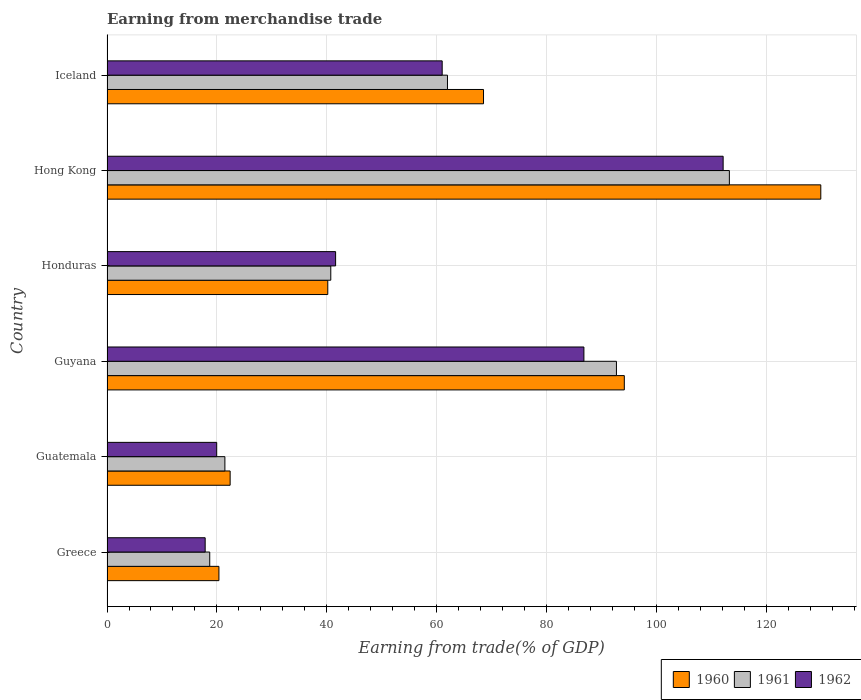How many different coloured bars are there?
Give a very brief answer. 3. How many groups of bars are there?
Offer a very short reply. 6. Are the number of bars on each tick of the Y-axis equal?
Your response must be concise. Yes. What is the label of the 4th group of bars from the top?
Provide a short and direct response. Guyana. In how many cases, is the number of bars for a given country not equal to the number of legend labels?
Keep it short and to the point. 0. What is the earnings from trade in 1961 in Iceland?
Your response must be concise. 61.93. Across all countries, what is the maximum earnings from trade in 1960?
Your response must be concise. 129.85. Across all countries, what is the minimum earnings from trade in 1961?
Give a very brief answer. 18.69. In which country was the earnings from trade in 1962 maximum?
Give a very brief answer. Hong Kong. What is the total earnings from trade in 1960 in the graph?
Offer a terse response. 375.36. What is the difference between the earnings from trade in 1962 in Guatemala and that in Iceland?
Your answer should be compact. -41.02. What is the difference between the earnings from trade in 1961 in Greece and the earnings from trade in 1962 in Hong Kong?
Provide a succinct answer. -93.39. What is the average earnings from trade in 1961 per country?
Offer a very short reply. 58.11. What is the difference between the earnings from trade in 1960 and earnings from trade in 1961 in Guyana?
Offer a terse response. 1.43. What is the ratio of the earnings from trade in 1960 in Guatemala to that in Hong Kong?
Ensure brevity in your answer.  0.17. What is the difference between the highest and the second highest earnings from trade in 1962?
Your answer should be very brief. 25.33. What is the difference between the highest and the lowest earnings from trade in 1962?
Offer a terse response. 94.22. Is the sum of the earnings from trade in 1961 in Guyana and Iceland greater than the maximum earnings from trade in 1960 across all countries?
Provide a succinct answer. Yes. What does the 2nd bar from the bottom in Hong Kong represents?
Offer a terse response. 1961. How many bars are there?
Offer a very short reply. 18. Are the values on the major ticks of X-axis written in scientific E-notation?
Offer a very short reply. No. Does the graph contain grids?
Offer a terse response. Yes. How many legend labels are there?
Provide a short and direct response. 3. What is the title of the graph?
Offer a terse response. Earning from merchandise trade. Does "1972" appear as one of the legend labels in the graph?
Give a very brief answer. No. What is the label or title of the X-axis?
Keep it short and to the point. Earning from trade(% of GDP). What is the label or title of the Y-axis?
Keep it short and to the point. Country. What is the Earning from trade(% of GDP) in 1960 in Greece?
Your answer should be compact. 20.36. What is the Earning from trade(% of GDP) of 1961 in Greece?
Provide a succinct answer. 18.69. What is the Earning from trade(% of GDP) in 1962 in Greece?
Offer a very short reply. 17.86. What is the Earning from trade(% of GDP) in 1960 in Guatemala?
Your answer should be compact. 22.4. What is the Earning from trade(% of GDP) of 1961 in Guatemala?
Make the answer very short. 21.44. What is the Earning from trade(% of GDP) in 1962 in Guatemala?
Make the answer very short. 19.96. What is the Earning from trade(% of GDP) in 1960 in Guyana?
Your answer should be very brief. 94.1. What is the Earning from trade(% of GDP) of 1961 in Guyana?
Make the answer very short. 92.67. What is the Earning from trade(% of GDP) in 1962 in Guyana?
Your answer should be compact. 86.75. What is the Earning from trade(% of GDP) in 1960 in Honduras?
Provide a short and direct response. 40.16. What is the Earning from trade(% of GDP) of 1961 in Honduras?
Keep it short and to the point. 40.71. What is the Earning from trade(% of GDP) in 1962 in Honduras?
Make the answer very short. 41.59. What is the Earning from trade(% of GDP) of 1960 in Hong Kong?
Provide a short and direct response. 129.85. What is the Earning from trade(% of GDP) of 1961 in Hong Kong?
Ensure brevity in your answer.  113.21. What is the Earning from trade(% of GDP) in 1962 in Hong Kong?
Make the answer very short. 112.08. What is the Earning from trade(% of GDP) in 1960 in Iceland?
Offer a very short reply. 68.49. What is the Earning from trade(% of GDP) in 1961 in Iceland?
Offer a very short reply. 61.93. What is the Earning from trade(% of GDP) in 1962 in Iceland?
Keep it short and to the point. 60.97. Across all countries, what is the maximum Earning from trade(% of GDP) in 1960?
Your answer should be very brief. 129.85. Across all countries, what is the maximum Earning from trade(% of GDP) in 1961?
Your answer should be compact. 113.21. Across all countries, what is the maximum Earning from trade(% of GDP) of 1962?
Offer a terse response. 112.08. Across all countries, what is the minimum Earning from trade(% of GDP) in 1960?
Provide a short and direct response. 20.36. Across all countries, what is the minimum Earning from trade(% of GDP) of 1961?
Make the answer very short. 18.69. Across all countries, what is the minimum Earning from trade(% of GDP) in 1962?
Your response must be concise. 17.86. What is the total Earning from trade(% of GDP) in 1960 in the graph?
Your answer should be very brief. 375.36. What is the total Earning from trade(% of GDP) of 1961 in the graph?
Offer a very short reply. 348.66. What is the total Earning from trade(% of GDP) of 1962 in the graph?
Provide a short and direct response. 339.2. What is the difference between the Earning from trade(% of GDP) of 1960 in Greece and that in Guatemala?
Your response must be concise. -2.04. What is the difference between the Earning from trade(% of GDP) in 1961 in Greece and that in Guatemala?
Keep it short and to the point. -2.76. What is the difference between the Earning from trade(% of GDP) in 1962 in Greece and that in Guatemala?
Offer a very short reply. -2.1. What is the difference between the Earning from trade(% of GDP) of 1960 in Greece and that in Guyana?
Make the answer very short. -73.74. What is the difference between the Earning from trade(% of GDP) of 1961 in Greece and that in Guyana?
Make the answer very short. -73.98. What is the difference between the Earning from trade(% of GDP) of 1962 in Greece and that in Guyana?
Ensure brevity in your answer.  -68.9. What is the difference between the Earning from trade(% of GDP) of 1960 in Greece and that in Honduras?
Offer a very short reply. -19.8. What is the difference between the Earning from trade(% of GDP) in 1961 in Greece and that in Honduras?
Make the answer very short. -22.02. What is the difference between the Earning from trade(% of GDP) of 1962 in Greece and that in Honduras?
Offer a terse response. -23.73. What is the difference between the Earning from trade(% of GDP) of 1960 in Greece and that in Hong Kong?
Keep it short and to the point. -109.49. What is the difference between the Earning from trade(% of GDP) in 1961 in Greece and that in Hong Kong?
Your answer should be very brief. -94.53. What is the difference between the Earning from trade(% of GDP) of 1962 in Greece and that in Hong Kong?
Make the answer very short. -94.22. What is the difference between the Earning from trade(% of GDP) of 1960 in Greece and that in Iceland?
Offer a terse response. -48.13. What is the difference between the Earning from trade(% of GDP) of 1961 in Greece and that in Iceland?
Ensure brevity in your answer.  -43.24. What is the difference between the Earning from trade(% of GDP) of 1962 in Greece and that in Iceland?
Provide a short and direct response. -43.12. What is the difference between the Earning from trade(% of GDP) of 1960 in Guatemala and that in Guyana?
Provide a succinct answer. -71.7. What is the difference between the Earning from trade(% of GDP) of 1961 in Guatemala and that in Guyana?
Your answer should be very brief. -71.23. What is the difference between the Earning from trade(% of GDP) in 1962 in Guatemala and that in Guyana?
Your answer should be compact. -66.8. What is the difference between the Earning from trade(% of GDP) in 1960 in Guatemala and that in Honduras?
Your answer should be compact. -17.76. What is the difference between the Earning from trade(% of GDP) of 1961 in Guatemala and that in Honduras?
Give a very brief answer. -19.26. What is the difference between the Earning from trade(% of GDP) of 1962 in Guatemala and that in Honduras?
Ensure brevity in your answer.  -21.63. What is the difference between the Earning from trade(% of GDP) in 1960 in Guatemala and that in Hong Kong?
Keep it short and to the point. -107.45. What is the difference between the Earning from trade(% of GDP) of 1961 in Guatemala and that in Hong Kong?
Offer a terse response. -91.77. What is the difference between the Earning from trade(% of GDP) of 1962 in Guatemala and that in Hong Kong?
Your answer should be compact. -92.13. What is the difference between the Earning from trade(% of GDP) of 1960 in Guatemala and that in Iceland?
Provide a succinct answer. -46.09. What is the difference between the Earning from trade(% of GDP) of 1961 in Guatemala and that in Iceland?
Give a very brief answer. -40.49. What is the difference between the Earning from trade(% of GDP) in 1962 in Guatemala and that in Iceland?
Offer a very short reply. -41.02. What is the difference between the Earning from trade(% of GDP) of 1960 in Guyana and that in Honduras?
Your answer should be very brief. 53.94. What is the difference between the Earning from trade(% of GDP) in 1961 in Guyana and that in Honduras?
Keep it short and to the point. 51.96. What is the difference between the Earning from trade(% of GDP) in 1962 in Guyana and that in Honduras?
Keep it short and to the point. 45.17. What is the difference between the Earning from trade(% of GDP) of 1960 in Guyana and that in Hong Kong?
Give a very brief answer. -35.74. What is the difference between the Earning from trade(% of GDP) of 1961 in Guyana and that in Hong Kong?
Provide a succinct answer. -20.54. What is the difference between the Earning from trade(% of GDP) in 1962 in Guyana and that in Hong Kong?
Offer a terse response. -25.33. What is the difference between the Earning from trade(% of GDP) in 1960 in Guyana and that in Iceland?
Provide a succinct answer. 25.61. What is the difference between the Earning from trade(% of GDP) in 1961 in Guyana and that in Iceland?
Ensure brevity in your answer.  30.74. What is the difference between the Earning from trade(% of GDP) in 1962 in Guyana and that in Iceland?
Keep it short and to the point. 25.78. What is the difference between the Earning from trade(% of GDP) of 1960 in Honduras and that in Hong Kong?
Offer a very short reply. -89.68. What is the difference between the Earning from trade(% of GDP) of 1961 in Honduras and that in Hong Kong?
Offer a very short reply. -72.51. What is the difference between the Earning from trade(% of GDP) of 1962 in Honduras and that in Hong Kong?
Offer a very short reply. -70.49. What is the difference between the Earning from trade(% of GDP) of 1960 in Honduras and that in Iceland?
Offer a terse response. -28.33. What is the difference between the Earning from trade(% of GDP) of 1961 in Honduras and that in Iceland?
Ensure brevity in your answer.  -21.23. What is the difference between the Earning from trade(% of GDP) of 1962 in Honduras and that in Iceland?
Provide a succinct answer. -19.39. What is the difference between the Earning from trade(% of GDP) in 1960 in Hong Kong and that in Iceland?
Your answer should be very brief. 61.35. What is the difference between the Earning from trade(% of GDP) of 1961 in Hong Kong and that in Iceland?
Make the answer very short. 51.28. What is the difference between the Earning from trade(% of GDP) of 1962 in Hong Kong and that in Iceland?
Make the answer very short. 51.11. What is the difference between the Earning from trade(% of GDP) of 1960 in Greece and the Earning from trade(% of GDP) of 1961 in Guatemala?
Offer a very short reply. -1.09. What is the difference between the Earning from trade(% of GDP) of 1960 in Greece and the Earning from trade(% of GDP) of 1962 in Guatemala?
Provide a short and direct response. 0.4. What is the difference between the Earning from trade(% of GDP) of 1961 in Greece and the Earning from trade(% of GDP) of 1962 in Guatemala?
Offer a very short reply. -1.27. What is the difference between the Earning from trade(% of GDP) in 1960 in Greece and the Earning from trade(% of GDP) in 1961 in Guyana?
Make the answer very short. -72.31. What is the difference between the Earning from trade(% of GDP) in 1960 in Greece and the Earning from trade(% of GDP) in 1962 in Guyana?
Keep it short and to the point. -66.4. What is the difference between the Earning from trade(% of GDP) in 1961 in Greece and the Earning from trade(% of GDP) in 1962 in Guyana?
Your answer should be compact. -68.07. What is the difference between the Earning from trade(% of GDP) of 1960 in Greece and the Earning from trade(% of GDP) of 1961 in Honduras?
Your response must be concise. -20.35. What is the difference between the Earning from trade(% of GDP) of 1960 in Greece and the Earning from trade(% of GDP) of 1962 in Honduras?
Offer a terse response. -21.23. What is the difference between the Earning from trade(% of GDP) in 1961 in Greece and the Earning from trade(% of GDP) in 1962 in Honduras?
Your answer should be very brief. -22.9. What is the difference between the Earning from trade(% of GDP) in 1960 in Greece and the Earning from trade(% of GDP) in 1961 in Hong Kong?
Your answer should be compact. -92.86. What is the difference between the Earning from trade(% of GDP) of 1960 in Greece and the Earning from trade(% of GDP) of 1962 in Hong Kong?
Offer a terse response. -91.72. What is the difference between the Earning from trade(% of GDP) in 1961 in Greece and the Earning from trade(% of GDP) in 1962 in Hong Kong?
Provide a succinct answer. -93.39. What is the difference between the Earning from trade(% of GDP) of 1960 in Greece and the Earning from trade(% of GDP) of 1961 in Iceland?
Provide a succinct answer. -41.58. What is the difference between the Earning from trade(% of GDP) of 1960 in Greece and the Earning from trade(% of GDP) of 1962 in Iceland?
Make the answer very short. -40.62. What is the difference between the Earning from trade(% of GDP) of 1961 in Greece and the Earning from trade(% of GDP) of 1962 in Iceland?
Offer a terse response. -42.28. What is the difference between the Earning from trade(% of GDP) in 1960 in Guatemala and the Earning from trade(% of GDP) in 1961 in Guyana?
Your answer should be very brief. -70.27. What is the difference between the Earning from trade(% of GDP) in 1960 in Guatemala and the Earning from trade(% of GDP) in 1962 in Guyana?
Make the answer very short. -64.35. What is the difference between the Earning from trade(% of GDP) in 1961 in Guatemala and the Earning from trade(% of GDP) in 1962 in Guyana?
Your response must be concise. -65.31. What is the difference between the Earning from trade(% of GDP) of 1960 in Guatemala and the Earning from trade(% of GDP) of 1961 in Honduras?
Provide a succinct answer. -18.31. What is the difference between the Earning from trade(% of GDP) of 1960 in Guatemala and the Earning from trade(% of GDP) of 1962 in Honduras?
Ensure brevity in your answer.  -19.19. What is the difference between the Earning from trade(% of GDP) in 1961 in Guatemala and the Earning from trade(% of GDP) in 1962 in Honduras?
Keep it short and to the point. -20.14. What is the difference between the Earning from trade(% of GDP) in 1960 in Guatemala and the Earning from trade(% of GDP) in 1961 in Hong Kong?
Provide a succinct answer. -90.81. What is the difference between the Earning from trade(% of GDP) in 1960 in Guatemala and the Earning from trade(% of GDP) in 1962 in Hong Kong?
Make the answer very short. -89.68. What is the difference between the Earning from trade(% of GDP) in 1961 in Guatemala and the Earning from trade(% of GDP) in 1962 in Hong Kong?
Give a very brief answer. -90.64. What is the difference between the Earning from trade(% of GDP) in 1960 in Guatemala and the Earning from trade(% of GDP) in 1961 in Iceland?
Provide a succinct answer. -39.53. What is the difference between the Earning from trade(% of GDP) in 1960 in Guatemala and the Earning from trade(% of GDP) in 1962 in Iceland?
Give a very brief answer. -38.57. What is the difference between the Earning from trade(% of GDP) in 1961 in Guatemala and the Earning from trade(% of GDP) in 1962 in Iceland?
Ensure brevity in your answer.  -39.53. What is the difference between the Earning from trade(% of GDP) in 1960 in Guyana and the Earning from trade(% of GDP) in 1961 in Honduras?
Keep it short and to the point. 53.39. What is the difference between the Earning from trade(% of GDP) of 1960 in Guyana and the Earning from trade(% of GDP) of 1962 in Honduras?
Give a very brief answer. 52.52. What is the difference between the Earning from trade(% of GDP) of 1961 in Guyana and the Earning from trade(% of GDP) of 1962 in Honduras?
Your response must be concise. 51.09. What is the difference between the Earning from trade(% of GDP) of 1960 in Guyana and the Earning from trade(% of GDP) of 1961 in Hong Kong?
Provide a succinct answer. -19.11. What is the difference between the Earning from trade(% of GDP) in 1960 in Guyana and the Earning from trade(% of GDP) in 1962 in Hong Kong?
Your answer should be very brief. -17.98. What is the difference between the Earning from trade(% of GDP) in 1961 in Guyana and the Earning from trade(% of GDP) in 1962 in Hong Kong?
Make the answer very short. -19.41. What is the difference between the Earning from trade(% of GDP) of 1960 in Guyana and the Earning from trade(% of GDP) of 1961 in Iceland?
Ensure brevity in your answer.  32.17. What is the difference between the Earning from trade(% of GDP) in 1960 in Guyana and the Earning from trade(% of GDP) in 1962 in Iceland?
Offer a terse response. 33.13. What is the difference between the Earning from trade(% of GDP) of 1961 in Guyana and the Earning from trade(% of GDP) of 1962 in Iceland?
Ensure brevity in your answer.  31.7. What is the difference between the Earning from trade(% of GDP) in 1960 in Honduras and the Earning from trade(% of GDP) in 1961 in Hong Kong?
Give a very brief answer. -73.05. What is the difference between the Earning from trade(% of GDP) in 1960 in Honduras and the Earning from trade(% of GDP) in 1962 in Hong Kong?
Offer a very short reply. -71.92. What is the difference between the Earning from trade(% of GDP) in 1961 in Honduras and the Earning from trade(% of GDP) in 1962 in Hong Kong?
Make the answer very short. -71.37. What is the difference between the Earning from trade(% of GDP) in 1960 in Honduras and the Earning from trade(% of GDP) in 1961 in Iceland?
Offer a terse response. -21.77. What is the difference between the Earning from trade(% of GDP) in 1960 in Honduras and the Earning from trade(% of GDP) in 1962 in Iceland?
Make the answer very short. -20.81. What is the difference between the Earning from trade(% of GDP) in 1961 in Honduras and the Earning from trade(% of GDP) in 1962 in Iceland?
Your response must be concise. -20.27. What is the difference between the Earning from trade(% of GDP) in 1960 in Hong Kong and the Earning from trade(% of GDP) in 1961 in Iceland?
Make the answer very short. 67.91. What is the difference between the Earning from trade(% of GDP) in 1960 in Hong Kong and the Earning from trade(% of GDP) in 1962 in Iceland?
Give a very brief answer. 68.87. What is the difference between the Earning from trade(% of GDP) of 1961 in Hong Kong and the Earning from trade(% of GDP) of 1962 in Iceland?
Give a very brief answer. 52.24. What is the average Earning from trade(% of GDP) of 1960 per country?
Give a very brief answer. 62.56. What is the average Earning from trade(% of GDP) of 1961 per country?
Keep it short and to the point. 58.11. What is the average Earning from trade(% of GDP) in 1962 per country?
Provide a short and direct response. 56.53. What is the difference between the Earning from trade(% of GDP) of 1960 and Earning from trade(% of GDP) of 1961 in Greece?
Ensure brevity in your answer.  1.67. What is the difference between the Earning from trade(% of GDP) of 1960 and Earning from trade(% of GDP) of 1962 in Greece?
Ensure brevity in your answer.  2.5. What is the difference between the Earning from trade(% of GDP) in 1961 and Earning from trade(% of GDP) in 1962 in Greece?
Provide a succinct answer. 0.83. What is the difference between the Earning from trade(% of GDP) of 1960 and Earning from trade(% of GDP) of 1961 in Guatemala?
Provide a succinct answer. 0.96. What is the difference between the Earning from trade(% of GDP) in 1960 and Earning from trade(% of GDP) in 1962 in Guatemala?
Provide a succinct answer. 2.44. What is the difference between the Earning from trade(% of GDP) of 1961 and Earning from trade(% of GDP) of 1962 in Guatemala?
Your answer should be compact. 1.49. What is the difference between the Earning from trade(% of GDP) of 1960 and Earning from trade(% of GDP) of 1961 in Guyana?
Keep it short and to the point. 1.43. What is the difference between the Earning from trade(% of GDP) of 1960 and Earning from trade(% of GDP) of 1962 in Guyana?
Your answer should be compact. 7.35. What is the difference between the Earning from trade(% of GDP) in 1961 and Earning from trade(% of GDP) in 1962 in Guyana?
Keep it short and to the point. 5.92. What is the difference between the Earning from trade(% of GDP) of 1960 and Earning from trade(% of GDP) of 1961 in Honduras?
Make the answer very short. -0.55. What is the difference between the Earning from trade(% of GDP) of 1960 and Earning from trade(% of GDP) of 1962 in Honduras?
Make the answer very short. -1.43. What is the difference between the Earning from trade(% of GDP) in 1961 and Earning from trade(% of GDP) in 1962 in Honduras?
Make the answer very short. -0.88. What is the difference between the Earning from trade(% of GDP) of 1960 and Earning from trade(% of GDP) of 1961 in Hong Kong?
Provide a short and direct response. 16.63. What is the difference between the Earning from trade(% of GDP) of 1960 and Earning from trade(% of GDP) of 1962 in Hong Kong?
Offer a very short reply. 17.76. What is the difference between the Earning from trade(% of GDP) of 1961 and Earning from trade(% of GDP) of 1962 in Hong Kong?
Your response must be concise. 1.13. What is the difference between the Earning from trade(% of GDP) of 1960 and Earning from trade(% of GDP) of 1961 in Iceland?
Your answer should be compact. 6.56. What is the difference between the Earning from trade(% of GDP) of 1960 and Earning from trade(% of GDP) of 1962 in Iceland?
Keep it short and to the point. 7.52. What is the difference between the Earning from trade(% of GDP) of 1961 and Earning from trade(% of GDP) of 1962 in Iceland?
Offer a terse response. 0.96. What is the ratio of the Earning from trade(% of GDP) in 1960 in Greece to that in Guatemala?
Provide a succinct answer. 0.91. What is the ratio of the Earning from trade(% of GDP) of 1961 in Greece to that in Guatemala?
Make the answer very short. 0.87. What is the ratio of the Earning from trade(% of GDP) in 1962 in Greece to that in Guatemala?
Ensure brevity in your answer.  0.89. What is the ratio of the Earning from trade(% of GDP) in 1960 in Greece to that in Guyana?
Make the answer very short. 0.22. What is the ratio of the Earning from trade(% of GDP) of 1961 in Greece to that in Guyana?
Your response must be concise. 0.2. What is the ratio of the Earning from trade(% of GDP) in 1962 in Greece to that in Guyana?
Provide a succinct answer. 0.21. What is the ratio of the Earning from trade(% of GDP) in 1960 in Greece to that in Honduras?
Make the answer very short. 0.51. What is the ratio of the Earning from trade(% of GDP) of 1961 in Greece to that in Honduras?
Give a very brief answer. 0.46. What is the ratio of the Earning from trade(% of GDP) of 1962 in Greece to that in Honduras?
Your answer should be compact. 0.43. What is the ratio of the Earning from trade(% of GDP) of 1960 in Greece to that in Hong Kong?
Your answer should be very brief. 0.16. What is the ratio of the Earning from trade(% of GDP) of 1961 in Greece to that in Hong Kong?
Provide a succinct answer. 0.17. What is the ratio of the Earning from trade(% of GDP) in 1962 in Greece to that in Hong Kong?
Provide a short and direct response. 0.16. What is the ratio of the Earning from trade(% of GDP) in 1960 in Greece to that in Iceland?
Ensure brevity in your answer.  0.3. What is the ratio of the Earning from trade(% of GDP) in 1961 in Greece to that in Iceland?
Keep it short and to the point. 0.3. What is the ratio of the Earning from trade(% of GDP) of 1962 in Greece to that in Iceland?
Keep it short and to the point. 0.29. What is the ratio of the Earning from trade(% of GDP) in 1960 in Guatemala to that in Guyana?
Ensure brevity in your answer.  0.24. What is the ratio of the Earning from trade(% of GDP) in 1961 in Guatemala to that in Guyana?
Ensure brevity in your answer.  0.23. What is the ratio of the Earning from trade(% of GDP) in 1962 in Guatemala to that in Guyana?
Your answer should be compact. 0.23. What is the ratio of the Earning from trade(% of GDP) of 1960 in Guatemala to that in Honduras?
Your response must be concise. 0.56. What is the ratio of the Earning from trade(% of GDP) in 1961 in Guatemala to that in Honduras?
Provide a succinct answer. 0.53. What is the ratio of the Earning from trade(% of GDP) of 1962 in Guatemala to that in Honduras?
Ensure brevity in your answer.  0.48. What is the ratio of the Earning from trade(% of GDP) in 1960 in Guatemala to that in Hong Kong?
Offer a terse response. 0.17. What is the ratio of the Earning from trade(% of GDP) in 1961 in Guatemala to that in Hong Kong?
Give a very brief answer. 0.19. What is the ratio of the Earning from trade(% of GDP) of 1962 in Guatemala to that in Hong Kong?
Keep it short and to the point. 0.18. What is the ratio of the Earning from trade(% of GDP) of 1960 in Guatemala to that in Iceland?
Ensure brevity in your answer.  0.33. What is the ratio of the Earning from trade(% of GDP) of 1961 in Guatemala to that in Iceland?
Make the answer very short. 0.35. What is the ratio of the Earning from trade(% of GDP) in 1962 in Guatemala to that in Iceland?
Provide a short and direct response. 0.33. What is the ratio of the Earning from trade(% of GDP) of 1960 in Guyana to that in Honduras?
Your answer should be compact. 2.34. What is the ratio of the Earning from trade(% of GDP) in 1961 in Guyana to that in Honduras?
Your response must be concise. 2.28. What is the ratio of the Earning from trade(% of GDP) in 1962 in Guyana to that in Honduras?
Make the answer very short. 2.09. What is the ratio of the Earning from trade(% of GDP) in 1960 in Guyana to that in Hong Kong?
Give a very brief answer. 0.72. What is the ratio of the Earning from trade(% of GDP) in 1961 in Guyana to that in Hong Kong?
Your response must be concise. 0.82. What is the ratio of the Earning from trade(% of GDP) in 1962 in Guyana to that in Hong Kong?
Make the answer very short. 0.77. What is the ratio of the Earning from trade(% of GDP) of 1960 in Guyana to that in Iceland?
Offer a terse response. 1.37. What is the ratio of the Earning from trade(% of GDP) of 1961 in Guyana to that in Iceland?
Offer a very short reply. 1.5. What is the ratio of the Earning from trade(% of GDP) in 1962 in Guyana to that in Iceland?
Ensure brevity in your answer.  1.42. What is the ratio of the Earning from trade(% of GDP) in 1960 in Honduras to that in Hong Kong?
Keep it short and to the point. 0.31. What is the ratio of the Earning from trade(% of GDP) in 1961 in Honduras to that in Hong Kong?
Offer a very short reply. 0.36. What is the ratio of the Earning from trade(% of GDP) in 1962 in Honduras to that in Hong Kong?
Make the answer very short. 0.37. What is the ratio of the Earning from trade(% of GDP) in 1960 in Honduras to that in Iceland?
Your answer should be very brief. 0.59. What is the ratio of the Earning from trade(% of GDP) of 1961 in Honduras to that in Iceland?
Ensure brevity in your answer.  0.66. What is the ratio of the Earning from trade(% of GDP) of 1962 in Honduras to that in Iceland?
Keep it short and to the point. 0.68. What is the ratio of the Earning from trade(% of GDP) of 1960 in Hong Kong to that in Iceland?
Give a very brief answer. 1.9. What is the ratio of the Earning from trade(% of GDP) of 1961 in Hong Kong to that in Iceland?
Your answer should be compact. 1.83. What is the ratio of the Earning from trade(% of GDP) of 1962 in Hong Kong to that in Iceland?
Ensure brevity in your answer.  1.84. What is the difference between the highest and the second highest Earning from trade(% of GDP) in 1960?
Provide a short and direct response. 35.74. What is the difference between the highest and the second highest Earning from trade(% of GDP) of 1961?
Offer a terse response. 20.54. What is the difference between the highest and the second highest Earning from trade(% of GDP) in 1962?
Provide a succinct answer. 25.33. What is the difference between the highest and the lowest Earning from trade(% of GDP) in 1960?
Keep it short and to the point. 109.49. What is the difference between the highest and the lowest Earning from trade(% of GDP) in 1961?
Offer a terse response. 94.53. What is the difference between the highest and the lowest Earning from trade(% of GDP) in 1962?
Provide a short and direct response. 94.22. 